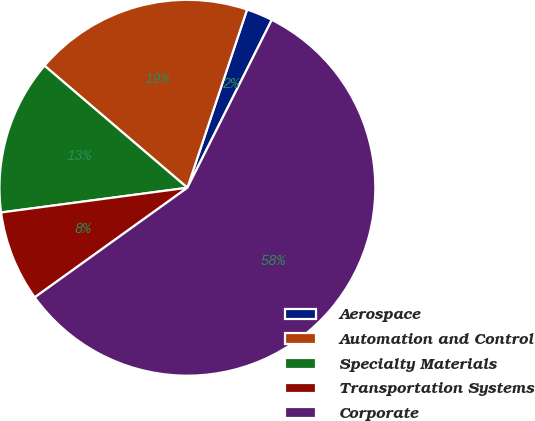<chart> <loc_0><loc_0><loc_500><loc_500><pie_chart><fcel>Aerospace<fcel>Automation and Control<fcel>Specialty Materials<fcel>Transportation Systems<fcel>Corporate<nl><fcel>2.27%<fcel>18.89%<fcel>13.35%<fcel>7.81%<fcel>57.67%<nl></chart> 